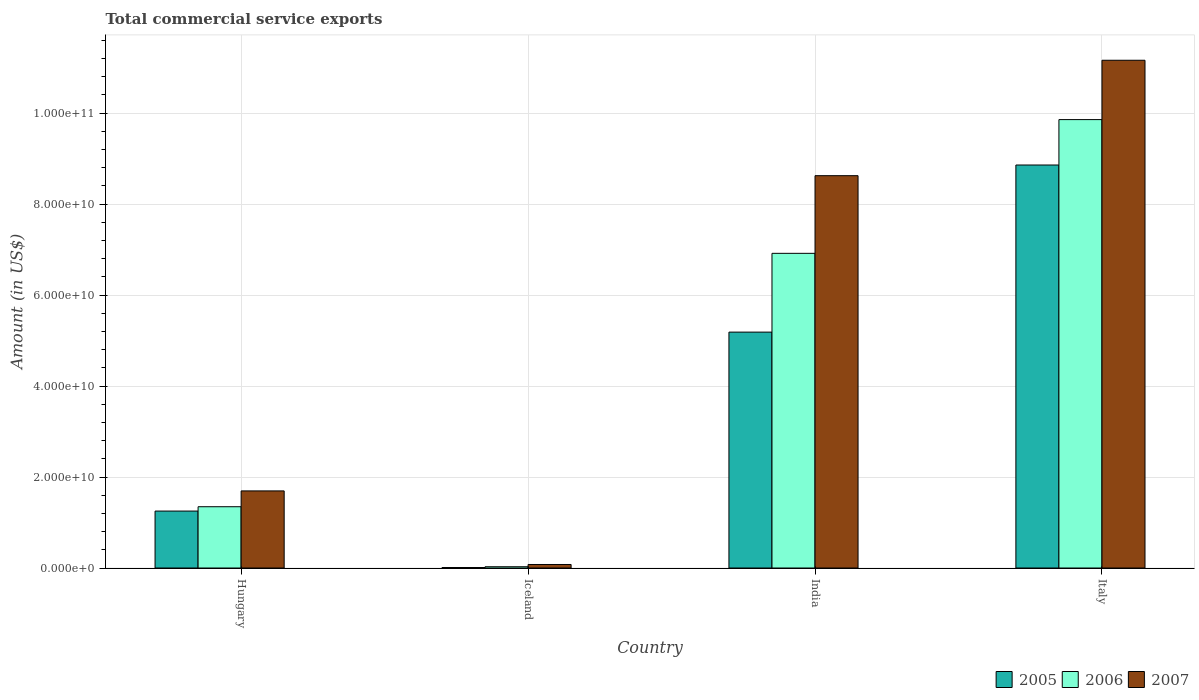How many groups of bars are there?
Provide a succinct answer. 4. How many bars are there on the 4th tick from the left?
Keep it short and to the point. 3. In how many cases, is the number of bars for a given country not equal to the number of legend labels?
Your answer should be very brief. 0. What is the total commercial service exports in 2005 in India?
Keep it short and to the point. 5.19e+1. Across all countries, what is the maximum total commercial service exports in 2006?
Keep it short and to the point. 9.86e+1. Across all countries, what is the minimum total commercial service exports in 2007?
Your response must be concise. 7.74e+08. In which country was the total commercial service exports in 2006 maximum?
Your answer should be very brief. Italy. In which country was the total commercial service exports in 2007 minimum?
Give a very brief answer. Iceland. What is the total total commercial service exports in 2007 in the graph?
Ensure brevity in your answer.  2.16e+11. What is the difference between the total commercial service exports in 2005 in Hungary and that in Italy?
Keep it short and to the point. -7.61e+1. What is the difference between the total commercial service exports in 2007 in Iceland and the total commercial service exports in 2005 in Italy?
Your answer should be very brief. -8.78e+1. What is the average total commercial service exports in 2005 per country?
Provide a succinct answer. 3.83e+1. What is the difference between the total commercial service exports of/in 2005 and total commercial service exports of/in 2007 in Hungary?
Keep it short and to the point. -4.43e+09. In how many countries, is the total commercial service exports in 2007 greater than 16000000000 US$?
Your response must be concise. 3. What is the ratio of the total commercial service exports in 2007 in Hungary to that in Iceland?
Your response must be concise. 21.91. Is the difference between the total commercial service exports in 2005 in Iceland and Italy greater than the difference between the total commercial service exports in 2007 in Iceland and Italy?
Your answer should be very brief. Yes. What is the difference between the highest and the second highest total commercial service exports in 2006?
Provide a succinct answer. -8.51e+1. What is the difference between the highest and the lowest total commercial service exports in 2007?
Provide a short and direct response. 1.11e+11. In how many countries, is the total commercial service exports in 2006 greater than the average total commercial service exports in 2006 taken over all countries?
Ensure brevity in your answer.  2. What does the 3rd bar from the left in Hungary represents?
Your response must be concise. 2007. What does the 2nd bar from the right in Iceland represents?
Offer a terse response. 2006. Is it the case that in every country, the sum of the total commercial service exports in 2005 and total commercial service exports in 2007 is greater than the total commercial service exports in 2006?
Offer a very short reply. Yes. Are the values on the major ticks of Y-axis written in scientific E-notation?
Offer a terse response. Yes. Does the graph contain any zero values?
Your answer should be very brief. No. Does the graph contain grids?
Your answer should be compact. Yes. How many legend labels are there?
Ensure brevity in your answer.  3. What is the title of the graph?
Give a very brief answer. Total commercial service exports. Does "1965" appear as one of the legend labels in the graph?
Provide a short and direct response. No. What is the Amount (in US$) of 2005 in Hungary?
Offer a terse response. 1.25e+1. What is the Amount (in US$) in 2006 in Hungary?
Your answer should be very brief. 1.35e+1. What is the Amount (in US$) of 2007 in Hungary?
Make the answer very short. 1.69e+1. What is the Amount (in US$) in 2005 in Iceland?
Your answer should be very brief. 1.06e+08. What is the Amount (in US$) of 2006 in Iceland?
Ensure brevity in your answer.  2.80e+08. What is the Amount (in US$) in 2007 in Iceland?
Your response must be concise. 7.74e+08. What is the Amount (in US$) in 2005 in India?
Keep it short and to the point. 5.19e+1. What is the Amount (in US$) in 2006 in India?
Offer a very short reply. 6.92e+1. What is the Amount (in US$) in 2007 in India?
Provide a short and direct response. 8.62e+1. What is the Amount (in US$) in 2005 in Italy?
Keep it short and to the point. 8.86e+1. What is the Amount (in US$) of 2006 in Italy?
Your answer should be compact. 9.86e+1. What is the Amount (in US$) of 2007 in Italy?
Your answer should be very brief. 1.12e+11. Across all countries, what is the maximum Amount (in US$) in 2005?
Keep it short and to the point. 8.86e+1. Across all countries, what is the maximum Amount (in US$) of 2006?
Your answer should be compact. 9.86e+1. Across all countries, what is the maximum Amount (in US$) in 2007?
Ensure brevity in your answer.  1.12e+11. Across all countries, what is the minimum Amount (in US$) in 2005?
Your answer should be compact. 1.06e+08. Across all countries, what is the minimum Amount (in US$) in 2006?
Offer a terse response. 2.80e+08. Across all countries, what is the minimum Amount (in US$) in 2007?
Provide a succinct answer. 7.74e+08. What is the total Amount (in US$) of 2005 in the graph?
Ensure brevity in your answer.  1.53e+11. What is the total Amount (in US$) of 2006 in the graph?
Make the answer very short. 1.81e+11. What is the total Amount (in US$) of 2007 in the graph?
Your response must be concise. 2.16e+11. What is the difference between the Amount (in US$) of 2005 in Hungary and that in Iceland?
Ensure brevity in your answer.  1.24e+1. What is the difference between the Amount (in US$) of 2006 in Hungary and that in Iceland?
Provide a short and direct response. 1.32e+1. What is the difference between the Amount (in US$) in 2007 in Hungary and that in Iceland?
Ensure brevity in your answer.  1.62e+1. What is the difference between the Amount (in US$) in 2005 in Hungary and that in India?
Offer a terse response. -3.93e+1. What is the difference between the Amount (in US$) of 2006 in Hungary and that in India?
Give a very brief answer. -5.57e+1. What is the difference between the Amount (in US$) of 2007 in Hungary and that in India?
Keep it short and to the point. -6.93e+1. What is the difference between the Amount (in US$) of 2005 in Hungary and that in Italy?
Offer a terse response. -7.61e+1. What is the difference between the Amount (in US$) in 2006 in Hungary and that in Italy?
Offer a very short reply. -8.51e+1. What is the difference between the Amount (in US$) in 2007 in Hungary and that in Italy?
Offer a terse response. -9.47e+1. What is the difference between the Amount (in US$) of 2005 in Iceland and that in India?
Give a very brief answer. -5.17e+1. What is the difference between the Amount (in US$) of 2006 in Iceland and that in India?
Ensure brevity in your answer.  -6.89e+1. What is the difference between the Amount (in US$) of 2007 in Iceland and that in India?
Give a very brief answer. -8.55e+1. What is the difference between the Amount (in US$) of 2005 in Iceland and that in Italy?
Your response must be concise. -8.85e+1. What is the difference between the Amount (in US$) of 2006 in Iceland and that in Italy?
Ensure brevity in your answer.  -9.83e+1. What is the difference between the Amount (in US$) of 2007 in Iceland and that in Italy?
Your response must be concise. -1.11e+11. What is the difference between the Amount (in US$) in 2005 in India and that in Italy?
Your answer should be very brief. -3.67e+1. What is the difference between the Amount (in US$) in 2006 in India and that in Italy?
Offer a terse response. -2.94e+1. What is the difference between the Amount (in US$) in 2007 in India and that in Italy?
Offer a very short reply. -2.54e+1. What is the difference between the Amount (in US$) of 2005 in Hungary and the Amount (in US$) of 2006 in Iceland?
Your answer should be very brief. 1.22e+1. What is the difference between the Amount (in US$) of 2005 in Hungary and the Amount (in US$) of 2007 in Iceland?
Your answer should be very brief. 1.17e+1. What is the difference between the Amount (in US$) in 2006 in Hungary and the Amount (in US$) in 2007 in Iceland?
Provide a short and direct response. 1.27e+1. What is the difference between the Amount (in US$) in 2005 in Hungary and the Amount (in US$) in 2006 in India?
Make the answer very short. -5.66e+1. What is the difference between the Amount (in US$) in 2005 in Hungary and the Amount (in US$) in 2007 in India?
Your response must be concise. -7.37e+1. What is the difference between the Amount (in US$) in 2006 in Hungary and the Amount (in US$) in 2007 in India?
Make the answer very short. -7.28e+1. What is the difference between the Amount (in US$) in 2005 in Hungary and the Amount (in US$) in 2006 in Italy?
Provide a succinct answer. -8.60e+1. What is the difference between the Amount (in US$) of 2005 in Hungary and the Amount (in US$) of 2007 in Italy?
Your answer should be compact. -9.91e+1. What is the difference between the Amount (in US$) of 2006 in Hungary and the Amount (in US$) of 2007 in Italy?
Give a very brief answer. -9.81e+1. What is the difference between the Amount (in US$) of 2005 in Iceland and the Amount (in US$) of 2006 in India?
Keep it short and to the point. -6.91e+1. What is the difference between the Amount (in US$) in 2005 in Iceland and the Amount (in US$) in 2007 in India?
Ensure brevity in your answer.  -8.61e+1. What is the difference between the Amount (in US$) of 2006 in Iceland and the Amount (in US$) of 2007 in India?
Your response must be concise. -8.60e+1. What is the difference between the Amount (in US$) of 2005 in Iceland and the Amount (in US$) of 2006 in Italy?
Give a very brief answer. -9.85e+1. What is the difference between the Amount (in US$) of 2005 in Iceland and the Amount (in US$) of 2007 in Italy?
Give a very brief answer. -1.11e+11. What is the difference between the Amount (in US$) of 2006 in Iceland and the Amount (in US$) of 2007 in Italy?
Your response must be concise. -1.11e+11. What is the difference between the Amount (in US$) of 2005 in India and the Amount (in US$) of 2006 in Italy?
Ensure brevity in your answer.  -4.67e+1. What is the difference between the Amount (in US$) of 2005 in India and the Amount (in US$) of 2007 in Italy?
Offer a very short reply. -5.98e+1. What is the difference between the Amount (in US$) of 2006 in India and the Amount (in US$) of 2007 in Italy?
Your answer should be compact. -4.24e+1. What is the average Amount (in US$) of 2005 per country?
Your answer should be compact. 3.83e+1. What is the average Amount (in US$) in 2006 per country?
Your answer should be very brief. 4.54e+1. What is the average Amount (in US$) in 2007 per country?
Ensure brevity in your answer.  5.39e+1. What is the difference between the Amount (in US$) of 2005 and Amount (in US$) of 2006 in Hungary?
Give a very brief answer. -9.54e+08. What is the difference between the Amount (in US$) of 2005 and Amount (in US$) of 2007 in Hungary?
Provide a short and direct response. -4.43e+09. What is the difference between the Amount (in US$) in 2006 and Amount (in US$) in 2007 in Hungary?
Your response must be concise. -3.48e+09. What is the difference between the Amount (in US$) in 2005 and Amount (in US$) in 2006 in Iceland?
Keep it short and to the point. -1.74e+08. What is the difference between the Amount (in US$) of 2005 and Amount (in US$) of 2007 in Iceland?
Ensure brevity in your answer.  -6.68e+08. What is the difference between the Amount (in US$) in 2006 and Amount (in US$) in 2007 in Iceland?
Ensure brevity in your answer.  -4.94e+08. What is the difference between the Amount (in US$) of 2005 and Amount (in US$) of 2006 in India?
Your response must be concise. -1.73e+1. What is the difference between the Amount (in US$) of 2005 and Amount (in US$) of 2007 in India?
Make the answer very short. -3.44e+1. What is the difference between the Amount (in US$) in 2006 and Amount (in US$) in 2007 in India?
Offer a terse response. -1.71e+1. What is the difference between the Amount (in US$) in 2005 and Amount (in US$) in 2006 in Italy?
Your answer should be compact. -9.98e+09. What is the difference between the Amount (in US$) of 2005 and Amount (in US$) of 2007 in Italy?
Give a very brief answer. -2.30e+1. What is the difference between the Amount (in US$) of 2006 and Amount (in US$) of 2007 in Italy?
Your response must be concise. -1.30e+1. What is the ratio of the Amount (in US$) in 2005 in Hungary to that in Iceland?
Provide a short and direct response. 118.29. What is the ratio of the Amount (in US$) of 2006 in Hungary to that in Iceland?
Offer a terse response. 48.12. What is the ratio of the Amount (in US$) in 2007 in Hungary to that in Iceland?
Keep it short and to the point. 21.91. What is the ratio of the Amount (in US$) of 2005 in Hungary to that in India?
Give a very brief answer. 0.24. What is the ratio of the Amount (in US$) in 2006 in Hungary to that in India?
Offer a terse response. 0.19. What is the ratio of the Amount (in US$) of 2007 in Hungary to that in India?
Make the answer very short. 0.2. What is the ratio of the Amount (in US$) in 2005 in Hungary to that in Italy?
Provide a succinct answer. 0.14. What is the ratio of the Amount (in US$) of 2006 in Hungary to that in Italy?
Provide a succinct answer. 0.14. What is the ratio of the Amount (in US$) in 2007 in Hungary to that in Italy?
Make the answer very short. 0.15. What is the ratio of the Amount (in US$) of 2005 in Iceland to that in India?
Keep it short and to the point. 0. What is the ratio of the Amount (in US$) in 2006 in Iceland to that in India?
Ensure brevity in your answer.  0. What is the ratio of the Amount (in US$) in 2007 in Iceland to that in India?
Your answer should be compact. 0.01. What is the ratio of the Amount (in US$) in 2005 in Iceland to that in Italy?
Keep it short and to the point. 0. What is the ratio of the Amount (in US$) of 2006 in Iceland to that in Italy?
Provide a succinct answer. 0. What is the ratio of the Amount (in US$) of 2007 in Iceland to that in Italy?
Keep it short and to the point. 0.01. What is the ratio of the Amount (in US$) of 2005 in India to that in Italy?
Keep it short and to the point. 0.59. What is the ratio of the Amount (in US$) in 2006 in India to that in Italy?
Make the answer very short. 0.7. What is the ratio of the Amount (in US$) of 2007 in India to that in Italy?
Provide a short and direct response. 0.77. What is the difference between the highest and the second highest Amount (in US$) of 2005?
Your answer should be very brief. 3.67e+1. What is the difference between the highest and the second highest Amount (in US$) in 2006?
Keep it short and to the point. 2.94e+1. What is the difference between the highest and the second highest Amount (in US$) of 2007?
Your response must be concise. 2.54e+1. What is the difference between the highest and the lowest Amount (in US$) of 2005?
Offer a very short reply. 8.85e+1. What is the difference between the highest and the lowest Amount (in US$) of 2006?
Keep it short and to the point. 9.83e+1. What is the difference between the highest and the lowest Amount (in US$) of 2007?
Your answer should be compact. 1.11e+11. 